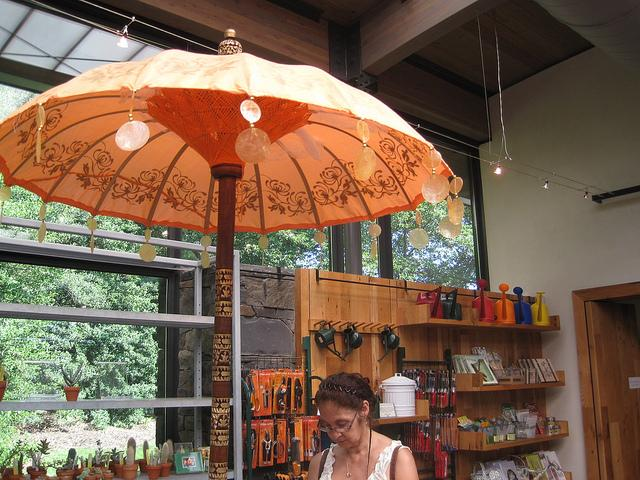What type of shop is this? garden 